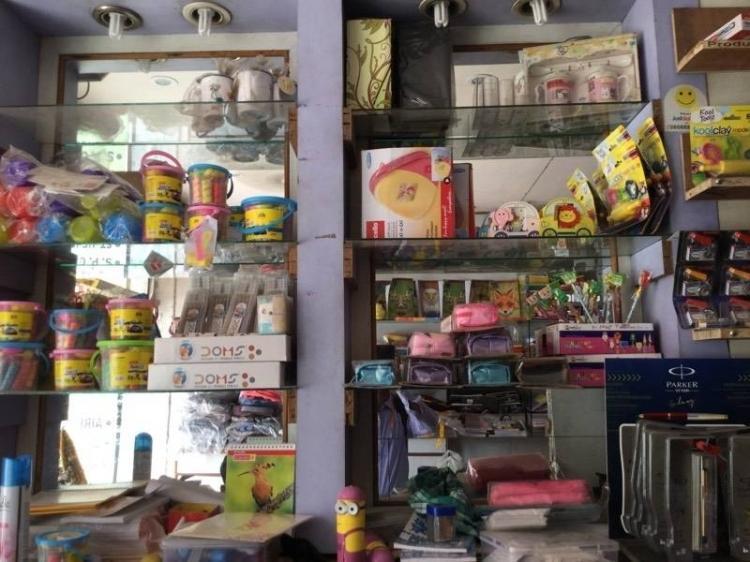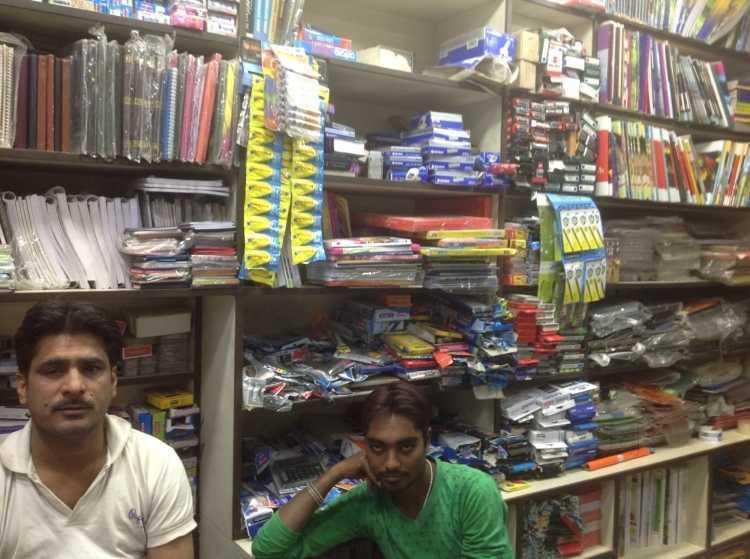The first image is the image on the left, the second image is the image on the right. Analyze the images presented: Is the assertion "All people are standing." valid? Answer yes or no. No. The first image is the image on the left, the second image is the image on the right. Evaluate the accuracy of this statement regarding the images: "All of the people in the shop are men.". Is it true? Answer yes or no. Yes. 